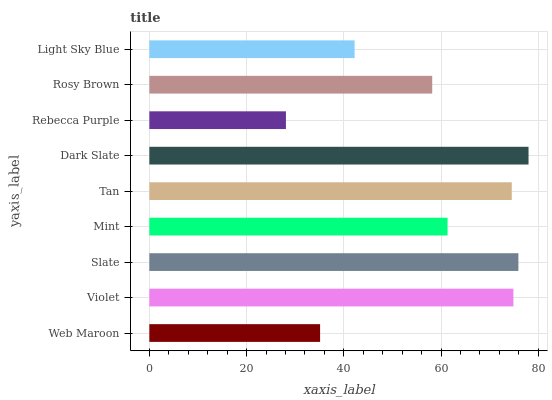Is Rebecca Purple the minimum?
Answer yes or no. Yes. Is Dark Slate the maximum?
Answer yes or no. Yes. Is Violet the minimum?
Answer yes or no. No. Is Violet the maximum?
Answer yes or no. No. Is Violet greater than Web Maroon?
Answer yes or no. Yes. Is Web Maroon less than Violet?
Answer yes or no. Yes. Is Web Maroon greater than Violet?
Answer yes or no. No. Is Violet less than Web Maroon?
Answer yes or no. No. Is Mint the high median?
Answer yes or no. Yes. Is Mint the low median?
Answer yes or no. Yes. Is Rosy Brown the high median?
Answer yes or no. No. Is Light Sky Blue the low median?
Answer yes or no. No. 